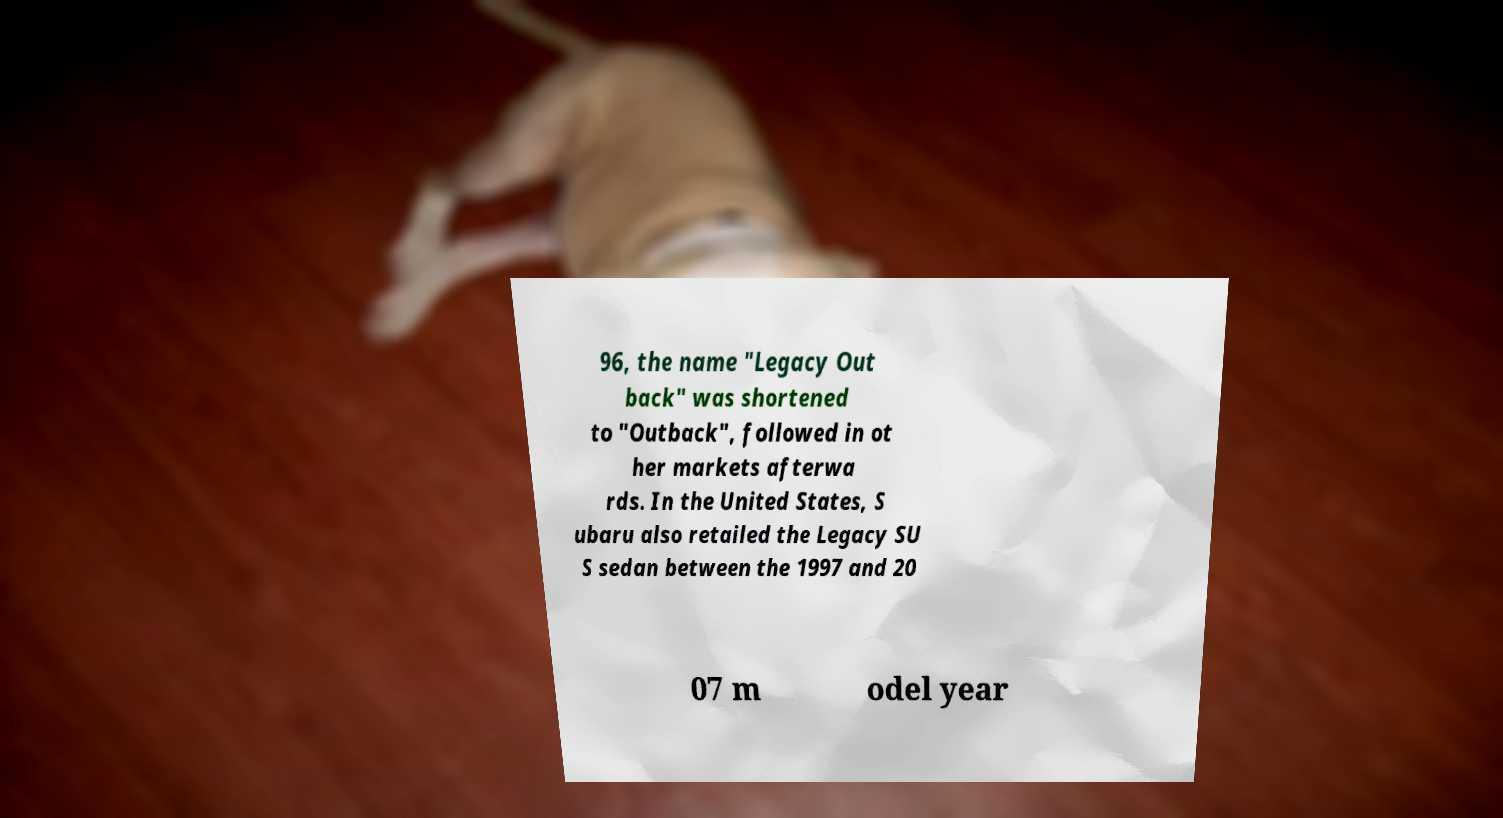Please read and relay the text visible in this image. What does it say? 96, the name "Legacy Out back" was shortened to "Outback", followed in ot her markets afterwa rds. In the United States, S ubaru also retailed the Legacy SU S sedan between the 1997 and 20 07 m odel year 